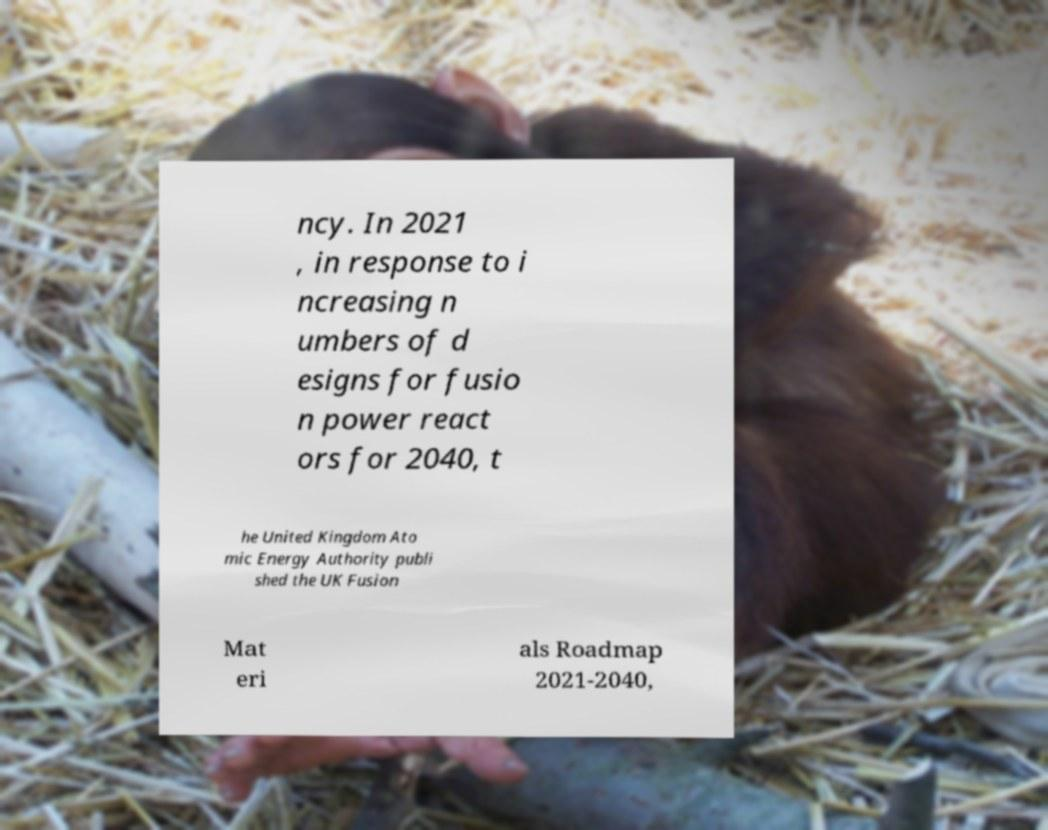What messages or text are displayed in this image? I need them in a readable, typed format. ncy. In 2021 , in response to i ncreasing n umbers of d esigns for fusio n power react ors for 2040, t he United Kingdom Ato mic Energy Authority publi shed the UK Fusion Mat eri als Roadmap 2021-2040, 